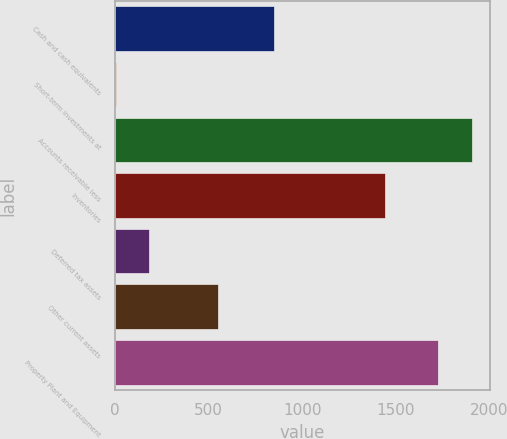Convert chart. <chart><loc_0><loc_0><loc_500><loc_500><bar_chart><fcel>Cash and cash equivalents<fcel>Short-term investments at<fcel>Accounts receivable less<fcel>Inventories<fcel>Deferred tax assets<fcel>Other current assets<fcel>Property Plant and Equipment<nl><fcel>851<fcel>4.3<fcel>1906.46<fcel>1443.3<fcel>184.36<fcel>549.3<fcel>1726.4<nl></chart> 